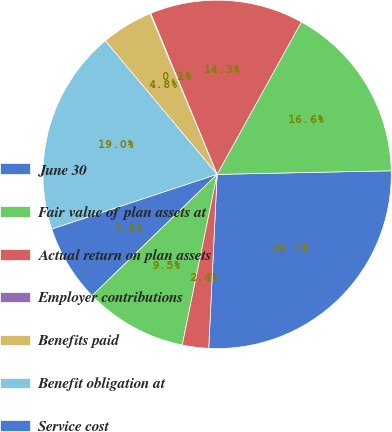Convert chart to OTSL. <chart><loc_0><loc_0><loc_500><loc_500><pie_chart><fcel>June 30<fcel>Fair value of plan assets at<fcel>Actual return on plan assets<fcel>Employer contributions<fcel>Benefits paid<fcel>Benefit obligation at<fcel>Service cost<fcel>Interest cost<fcel>Actuarial and other gains<nl><fcel>26.09%<fcel>16.63%<fcel>14.26%<fcel>0.07%<fcel>4.8%<fcel>18.99%<fcel>7.17%<fcel>9.53%<fcel>2.44%<nl></chart> 